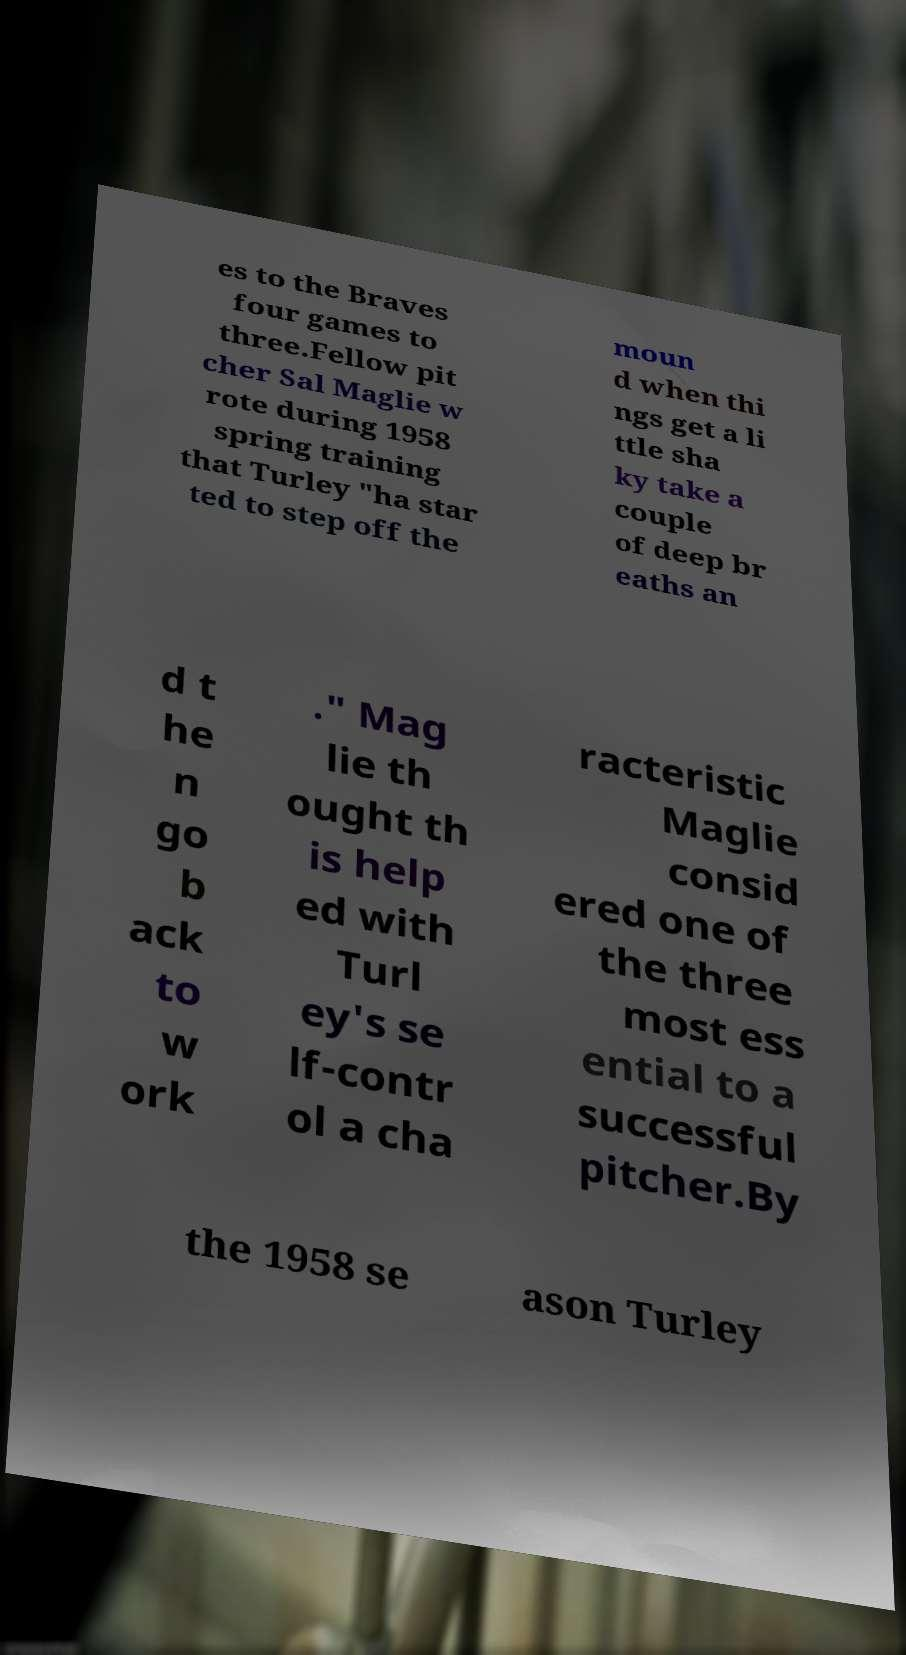Could you assist in decoding the text presented in this image and type it out clearly? es to the Braves four games to three.Fellow pit cher Sal Maglie w rote during 1958 spring training that Turley "ha star ted to step off the moun d when thi ngs get a li ttle sha ky take a couple of deep br eaths an d t he n go b ack to w ork ." Mag lie th ought th is help ed with Turl ey's se lf-contr ol a cha racteristic Maglie consid ered one of the three most ess ential to a successful pitcher.By the 1958 se ason Turley 